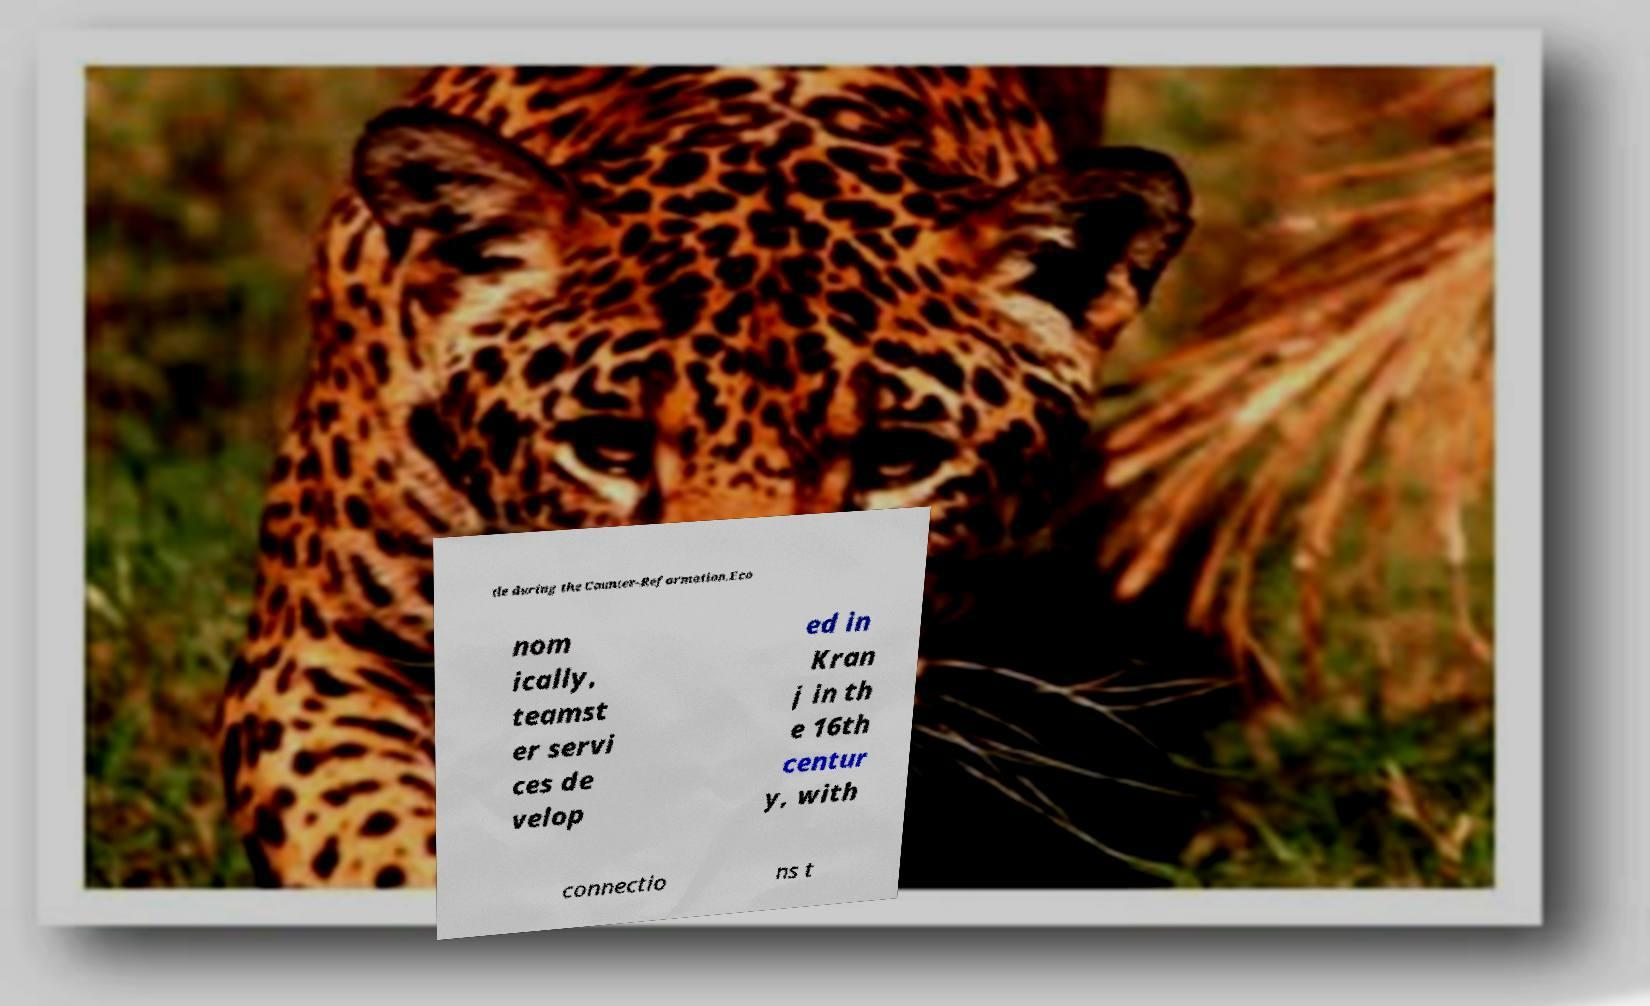There's text embedded in this image that I need extracted. Can you transcribe it verbatim? tle during the Counter-Reformation.Eco nom ically, teamst er servi ces de velop ed in Kran j in th e 16th centur y, with connectio ns t 